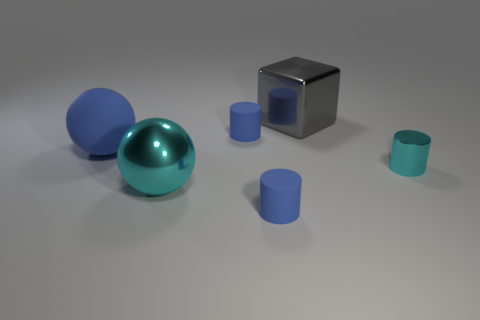Is the color of the big metal block the same as the big shiny ball?
Provide a succinct answer. No. What number of balls are gray things or cyan things?
Keep it short and to the point. 1. The cylinder that is in front of the big blue sphere and behind the shiny ball is made of what material?
Keep it short and to the point. Metal. What number of small matte cylinders are behind the small cyan metal cylinder?
Your response must be concise. 1. Does the blue object that is in front of the large shiny sphere have the same material as the cylinder on the right side of the gray shiny thing?
Provide a short and direct response. No. How many objects are either tiny blue rubber cylinders that are in front of the big blue ball or metallic cubes?
Your answer should be very brief. 2. Are there fewer rubber things behind the big blue rubber sphere than blue balls left of the small metal object?
Make the answer very short. No. How many other things are the same size as the cyan metal cylinder?
Make the answer very short. 2. Is the blue sphere made of the same material as the thing that is in front of the large cyan shiny ball?
Give a very brief answer. Yes. How many things are either tiny objects that are left of the big gray block or large things that are in front of the small metal cylinder?
Offer a very short reply. 3. 